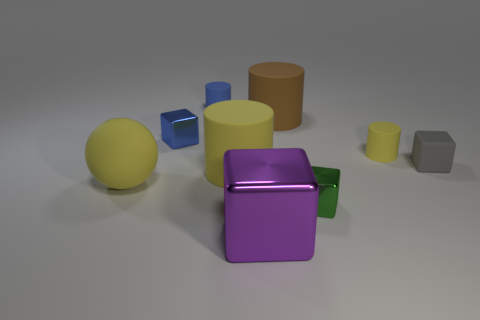Are there the same number of gray matte objects left of the small gray thing and blue rubber objects on the right side of the tiny blue cylinder?
Your answer should be compact. Yes. Is there a tiny yellow object?
Your response must be concise. Yes. What size is the other blue metal thing that is the same shape as the large shiny thing?
Your answer should be very brief. Small. What size is the yellow rubber thing left of the blue block?
Provide a succinct answer. Large. Are there more gray matte blocks that are in front of the tiny gray rubber block than small gray metallic balls?
Offer a terse response. No. What is the shape of the gray object?
Your answer should be very brief. Cube. There is a big matte object on the right side of the large yellow rubber cylinder; does it have the same color as the tiny object in front of the big ball?
Your answer should be compact. No. Is the shape of the large brown thing the same as the tiny yellow object?
Ensure brevity in your answer.  Yes. Are there any other things that have the same shape as the green shiny thing?
Your answer should be very brief. Yes. Is the tiny blue cube that is behind the tiny gray rubber block made of the same material as the tiny gray object?
Give a very brief answer. No. 